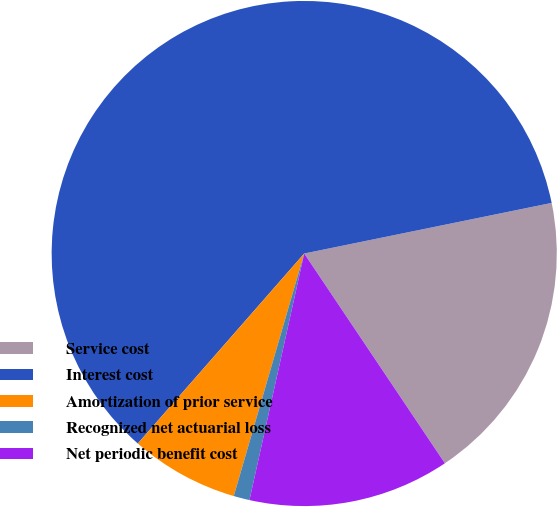Convert chart to OTSL. <chart><loc_0><loc_0><loc_500><loc_500><pie_chart><fcel>Service cost<fcel>Interest cost<fcel>Amortization of prior service<fcel>Recognized net actuarial loss<fcel>Net periodic benefit cost<nl><fcel>18.81%<fcel>60.34%<fcel>6.95%<fcel>1.02%<fcel>12.88%<nl></chart> 